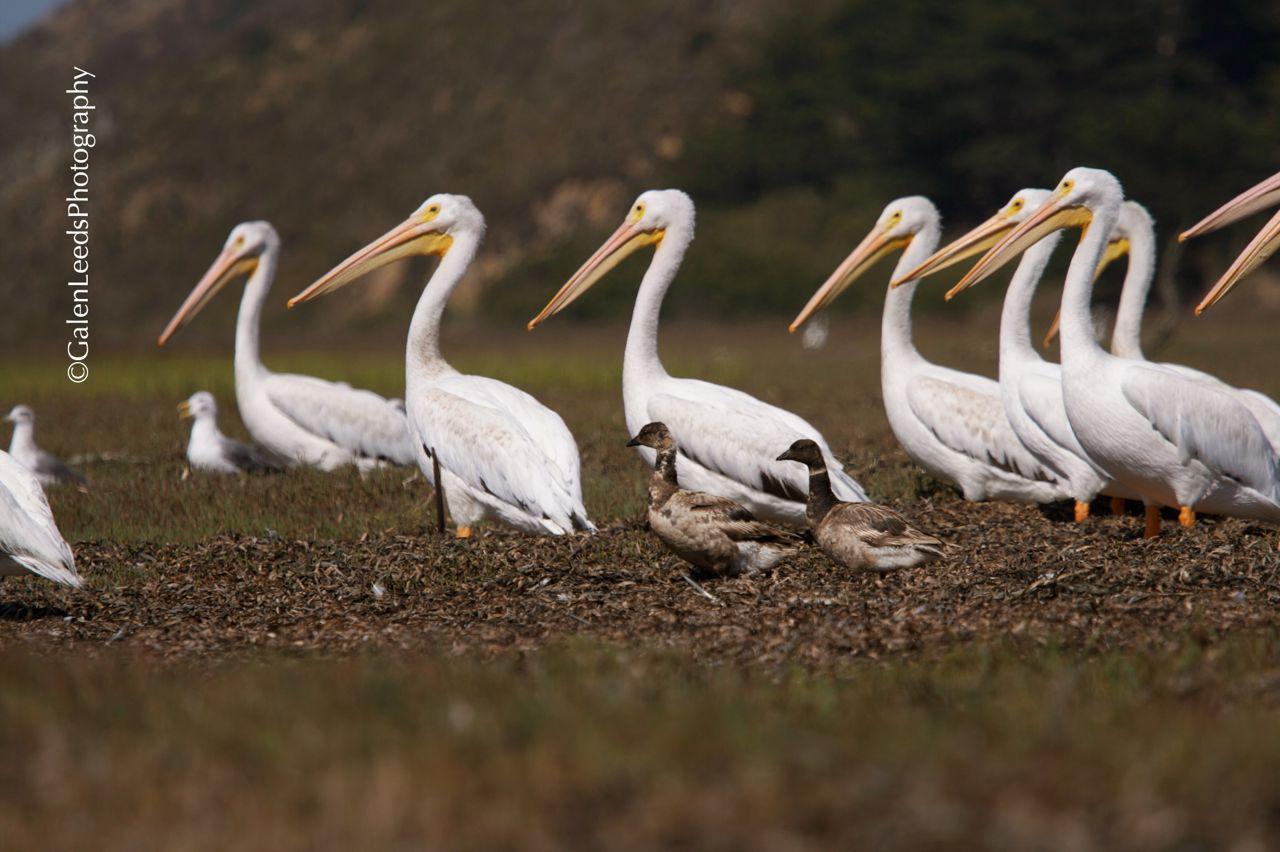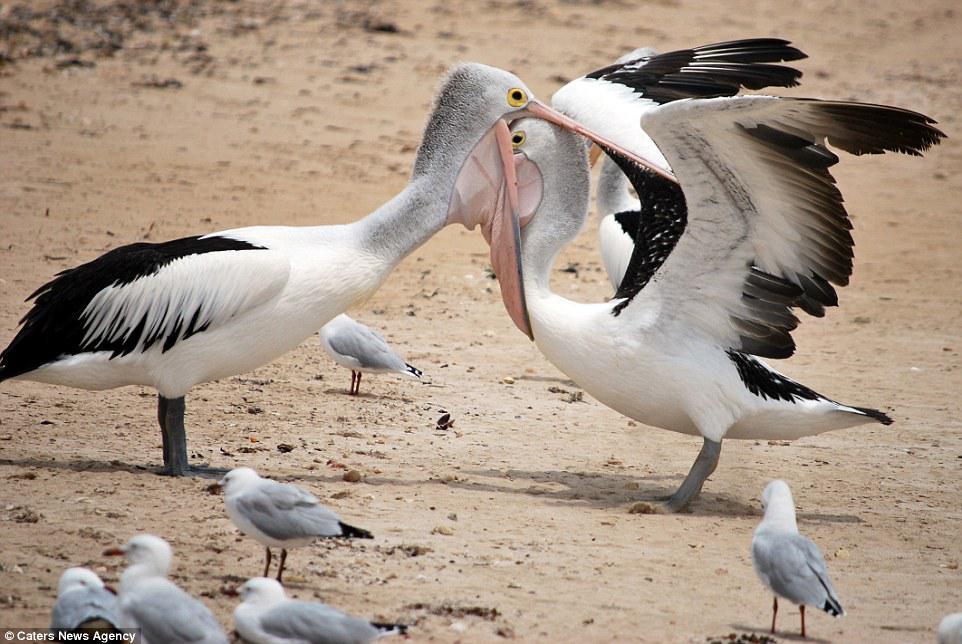The first image is the image on the left, the second image is the image on the right. Given the left and right images, does the statement "All the birds in the image on the left are floating on the water." hold true? Answer yes or no. No. The first image is the image on the left, the second image is the image on the right. Evaluate the accuracy of this statement regarding the images: "Left image shows left-facing pelicans floating on the water.". Is it true? Answer yes or no. No. 